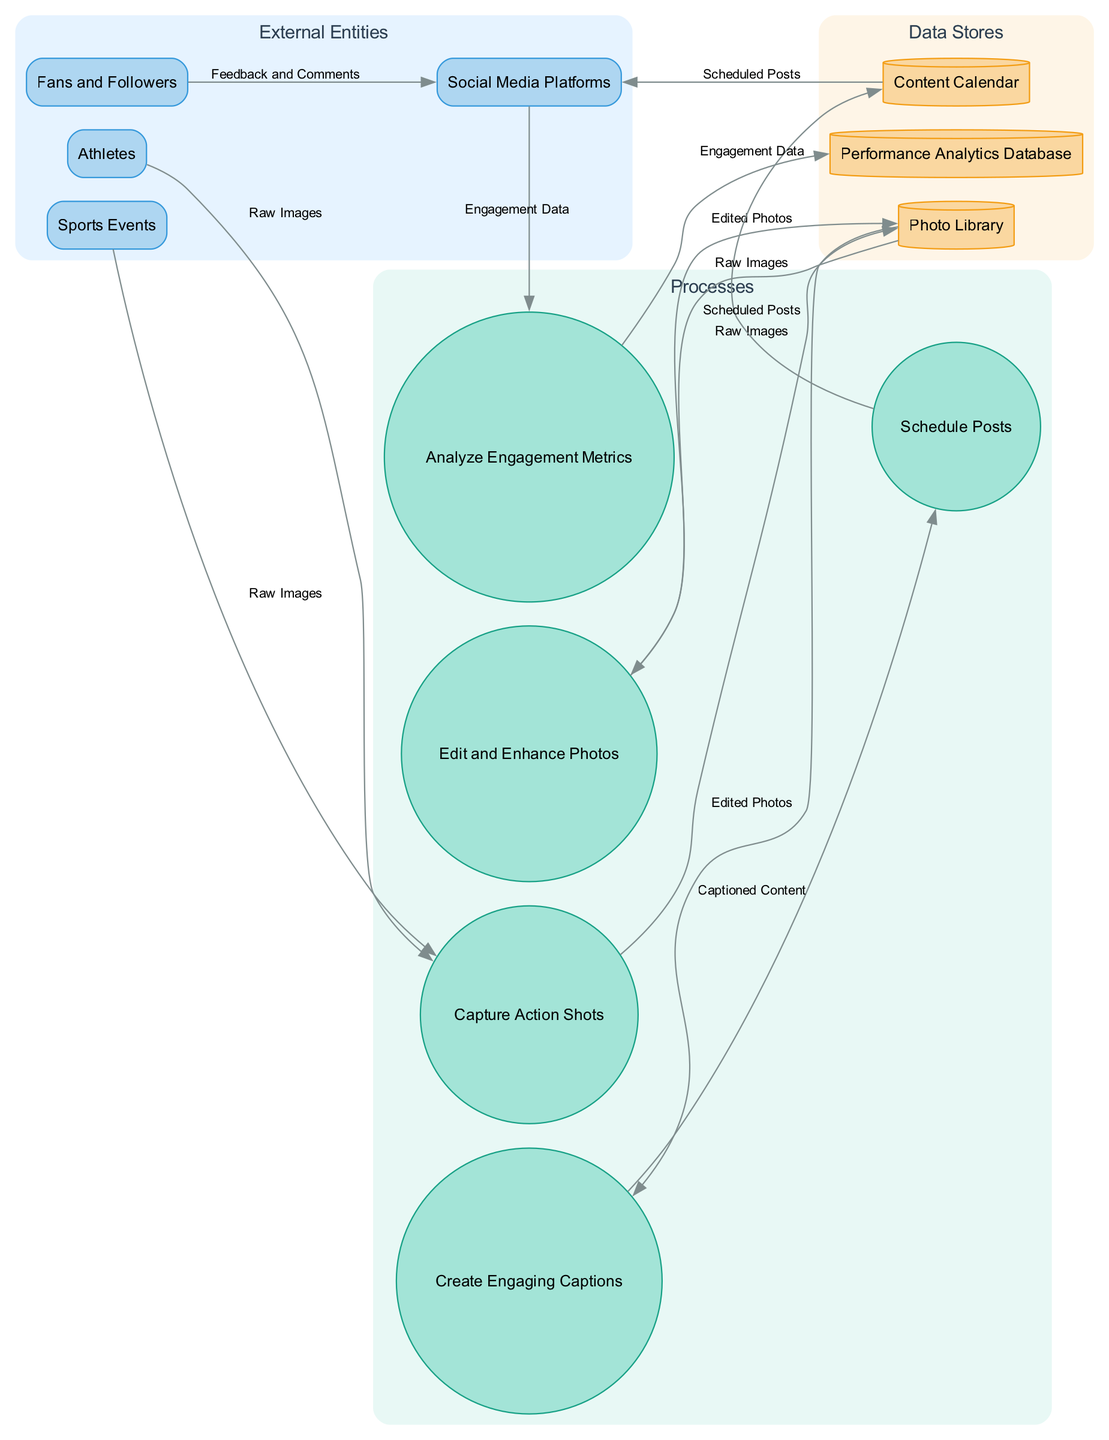What are the external entities in this diagram? The diagram lists several external entities which are sources of inputs to the workflow. I can find "Sports Events," "Athletes," "Social Media Platforms," and "Fans and Followers" as the entities depicted in the external section of the diagram.
Answer: Sports Events, Athletes, Social Media Platforms, Fans and Followers How many processes are represented in the diagram? The diagram includes a section for processes which details the main operations in the workflow. There are five distinct processes present: "Capture Action Shots," "Edit and Enhance Photos," "Create Engaging Captions," "Schedule Posts," and "Analyze Engagement Metrics." Counting these confirms the total.
Answer: 5 What is the data flow from "Create Engaging Captions" to "Schedule Posts"? The data flow indicates that after creating captions, the resulting output is "Captioned Content," which is passed onto the next step, "Schedule Posts." This is a direct flow indicated in the diagram.
Answer: Captioned Content Which process directly receives data from the "Photo Library"? Examining the flows from the "Photo Library," I can see it supplies data to "Edit and Enhance Photos" and "Create Engaging Captions." Both these processes receive data directly, but "Edit and Enhance Photos" is the first process to receive data from the "Photo Library."
Answer: Edit and Enhance Photos What type of relationship exists between "Social Media Platforms" and "Analyze Engagement Metrics"? The flow from "Social Media Platforms" to "Analyze Engagement Metrics" shows that engagement data gathered from social media is analyzed in the next step which implies a feedback loop where platforms provide data for analysis. This represents a workflow connection.
Answer: Data flow In which data store is "Engagement Data" analyzed? In the diagram, there is a specified data flow from "Analyze Engagement Metrics" leading to the "Performance Analytics Database" where the engagement data gets stored and analyzed. This indicates the data is sent here for storage and performance review.
Answer: Performance Analytics Database What data flows into the "Content Calendar"? By observing the flow direction, the "Scheduled Posts" data travels into the "Content Calendar." This indicates that the calendar is where posts are organized and scheduled for upcoming publication.
Answer: Scheduled Posts What feedback comes from "Fans and Followers"? The feedback loop indicates that "Fans and Followers" provide "Feedback and Comments" directly to the "Social Media Platforms," suggesting engagement or interaction based on the uploaded content. This is how fans express their responses.
Answer: Feedback and Comments 